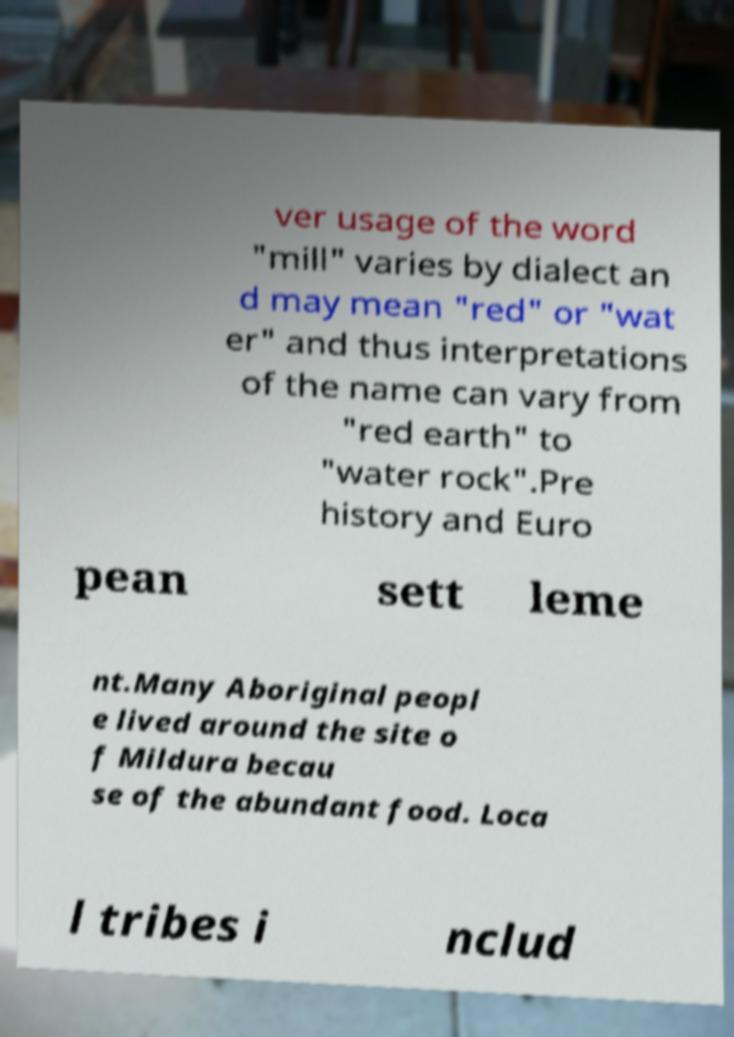Could you assist in decoding the text presented in this image and type it out clearly? ver usage of the word "mill" varies by dialect an d may mean "red" or "wat er" and thus interpretations of the name can vary from "red earth" to "water rock".Pre history and Euro pean sett leme nt.Many Aboriginal peopl e lived around the site o f Mildura becau se of the abundant food. Loca l tribes i nclud 